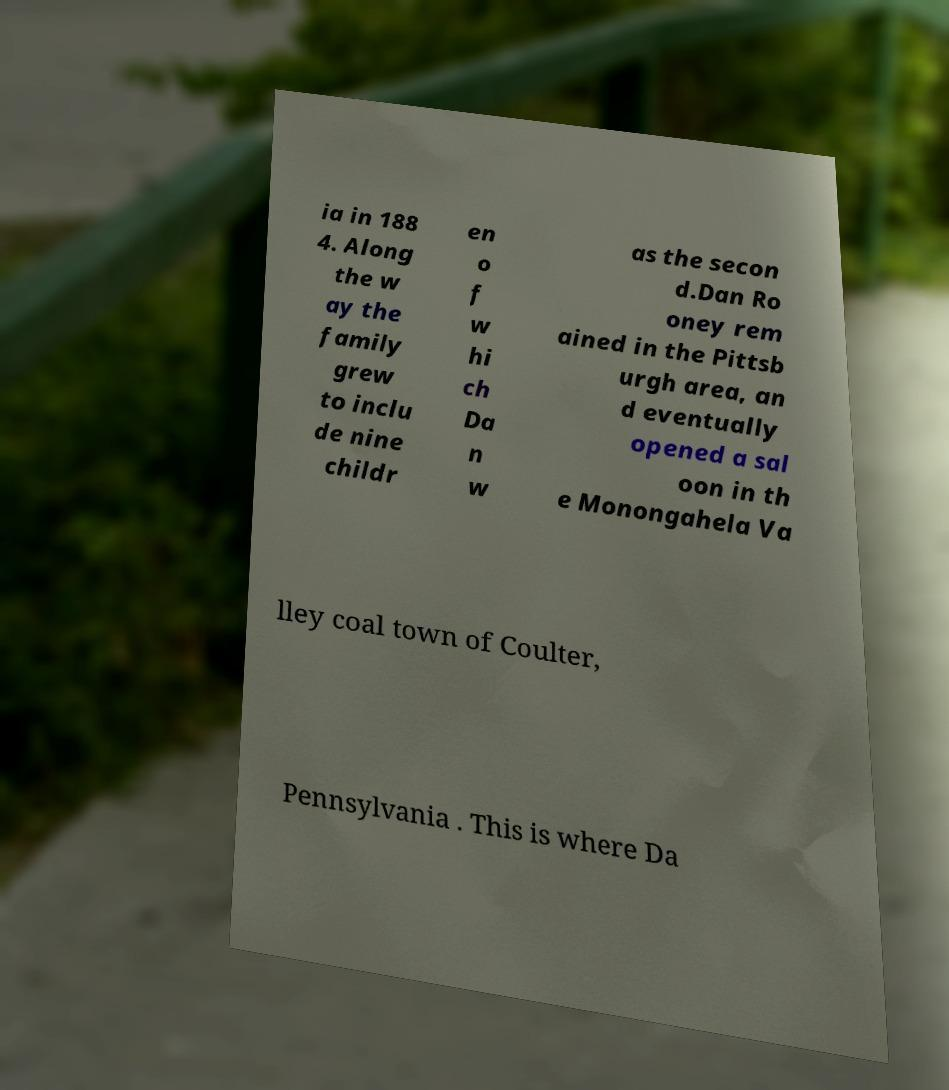Please identify and transcribe the text found in this image. ia in 188 4. Along the w ay the family grew to inclu de nine childr en o f w hi ch Da n w as the secon d.Dan Ro oney rem ained in the Pittsb urgh area, an d eventually opened a sal oon in th e Monongahela Va lley coal town of Coulter, Pennsylvania . This is where Da 